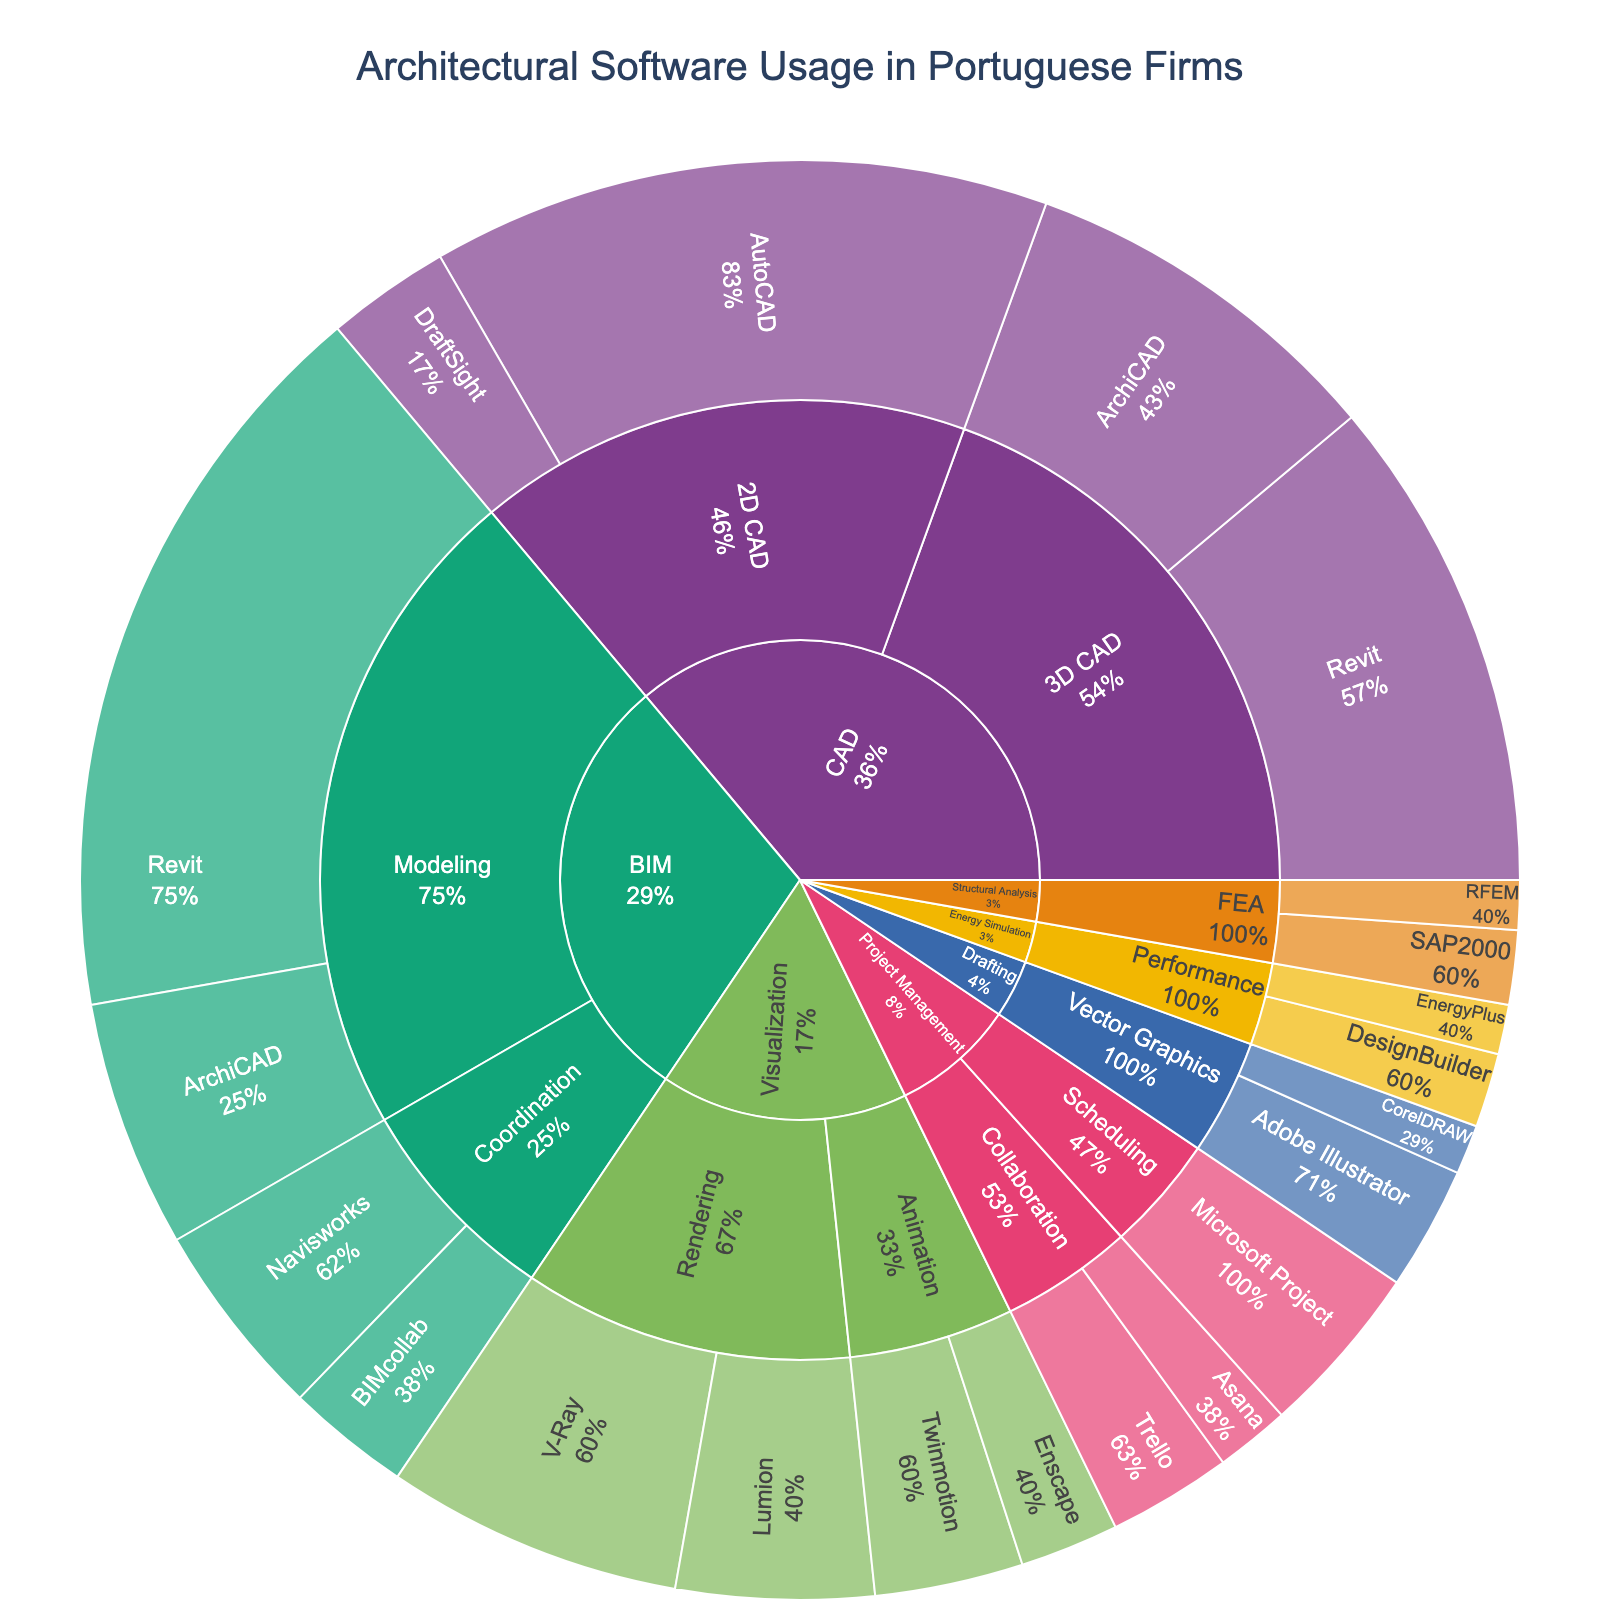What is the title of the Sunburst Plot? The title is usually found at the top center of the plot. This can be read directly from the plot's title text.
Answer: Architectural Software Usage in Portuguese Firms Which software has the highest usage percentage in the BIM category? To answer this, we look at the BIM section and identify the software with the highest percentage within this category.
Answer: Revit What is the total usage percentage of 2D CAD software? Add the usage percentages of AutoCAD and DraftSight under the 2D CAD subcategory within the CAD category: 25% + 5%.
Answer: 30% Compare the usage percentages of Revit in both CAD and BIM categories. Which usage is higher? Locate Revit under both CAD (3D CAD subcategory) and BIM (Modeling subcategory) and compare the usage percentages: 20% vs. 30%.
Answer: BIM What's the combined usage percentage of ArchiCAD across all categories? Sum the usage percentages of ArchiCAD found under the 3D CAD subcategory (15%) and the BIM Modeling subcategory (10%): 15% + 10%.
Answer: 25% Which software category has the most subcategories? Examine each category (CAD, BIM, Visualization, Project Management, Drafting, Structural Analysis, Energy Simulation) and count their subcategories.
Answer: CAD What is the least utilized software in the Architectural Visualization category? Within the Visualization category, locate each software and its usage percentage. The smallest percentage will identify the least utilized.
Answer: Enscape How does the usage percentage of V-Ray compare to Lumion in the Rendering subcategory? In the Visualization category under Rendering, compare the usage percentages of V-Ray and Lumion: 12% vs. 8%.
Answer: V-Ray is higher What is the total usage percentage of all Project Management software? Sum the percentages of Microsoft Project, Trello, and Asana under Project Management: 7% + 5% + 3%.
Answer: 15% Identify the software used for Structural Analysis with the lower usage percentage. Compare the percentages for SAP2000 and RFEM within Structural Analysis (FEA subcategory): 3% vs. 2%.
Answer: RFEM 